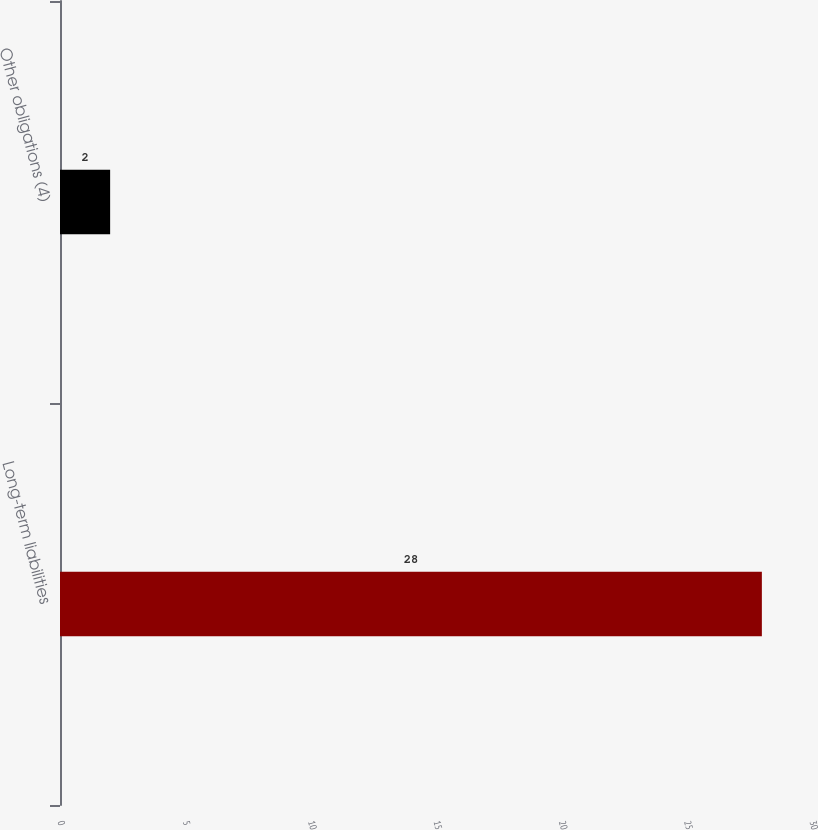Convert chart. <chart><loc_0><loc_0><loc_500><loc_500><bar_chart><fcel>Long-term liabilities<fcel>Other obligations (4)<nl><fcel>28<fcel>2<nl></chart> 